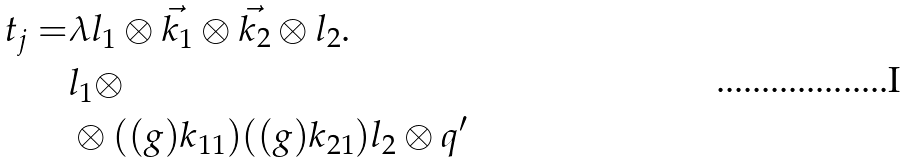<formula> <loc_0><loc_0><loc_500><loc_500>t _ { j } = & \lambda l _ { 1 } \otimes \vec { k _ { 1 } } \otimes \vec { k _ { 2 } } \otimes l _ { 2 } . \\ & l _ { 1 } \otimes \\ & \otimes ( ( g ) k _ { 1 1 } ) ( ( g ) k _ { 2 1 } ) l _ { 2 } \otimes q ^ { \prime }</formula> 